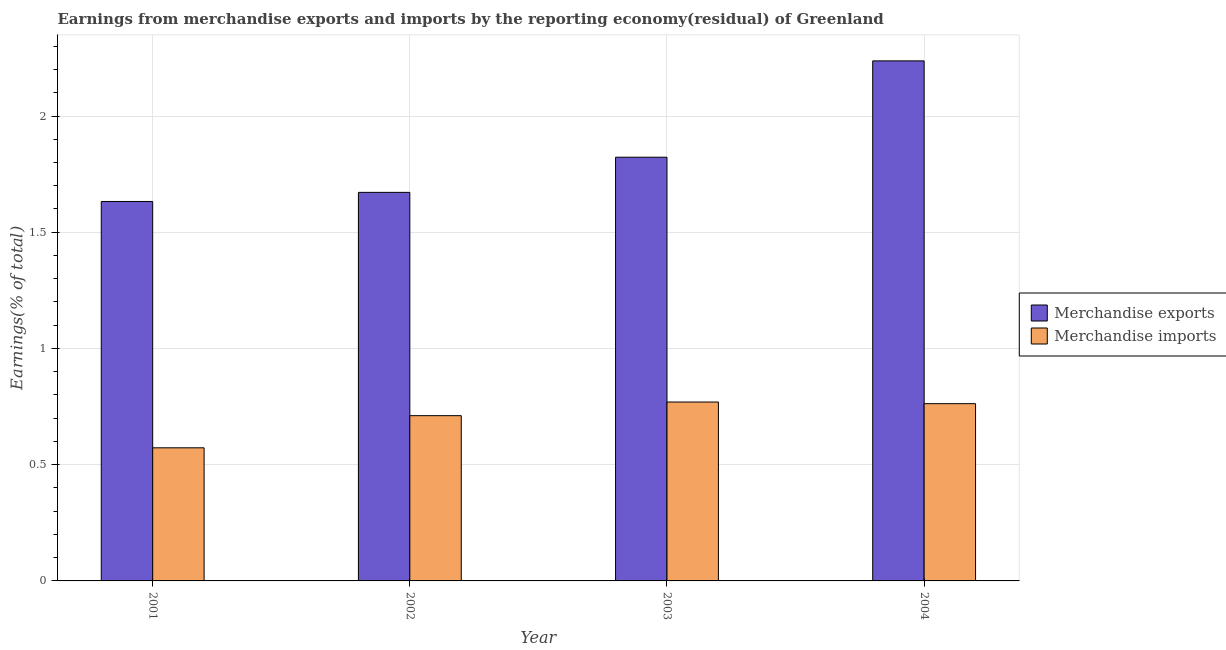What is the label of the 2nd group of bars from the left?
Offer a very short reply. 2002. What is the earnings from merchandise imports in 2002?
Offer a very short reply. 0.71. Across all years, what is the maximum earnings from merchandise exports?
Make the answer very short. 2.24. Across all years, what is the minimum earnings from merchandise exports?
Your answer should be very brief. 1.63. In which year was the earnings from merchandise imports maximum?
Your answer should be very brief. 2003. What is the total earnings from merchandise imports in the graph?
Keep it short and to the point. 2.82. What is the difference between the earnings from merchandise exports in 2001 and that in 2004?
Make the answer very short. -0.6. What is the difference between the earnings from merchandise exports in 2001 and the earnings from merchandise imports in 2004?
Provide a short and direct response. -0.6. What is the average earnings from merchandise exports per year?
Offer a very short reply. 1.84. In how many years, is the earnings from merchandise exports greater than 0.2 %?
Offer a terse response. 4. What is the ratio of the earnings from merchandise imports in 2001 to that in 2003?
Give a very brief answer. 0.74. What is the difference between the highest and the second highest earnings from merchandise imports?
Your answer should be compact. 0.01. What is the difference between the highest and the lowest earnings from merchandise imports?
Keep it short and to the point. 0.2. In how many years, is the earnings from merchandise exports greater than the average earnings from merchandise exports taken over all years?
Ensure brevity in your answer.  1. What does the 1st bar from the right in 2003 represents?
Offer a very short reply. Merchandise imports. Are all the bars in the graph horizontal?
Offer a terse response. No. How many years are there in the graph?
Keep it short and to the point. 4. Are the values on the major ticks of Y-axis written in scientific E-notation?
Give a very brief answer. No. Does the graph contain grids?
Give a very brief answer. Yes. How are the legend labels stacked?
Offer a very short reply. Vertical. What is the title of the graph?
Offer a very short reply. Earnings from merchandise exports and imports by the reporting economy(residual) of Greenland. What is the label or title of the X-axis?
Make the answer very short. Year. What is the label or title of the Y-axis?
Your answer should be very brief. Earnings(% of total). What is the Earnings(% of total) in Merchandise exports in 2001?
Ensure brevity in your answer.  1.63. What is the Earnings(% of total) in Merchandise imports in 2001?
Give a very brief answer. 0.57. What is the Earnings(% of total) in Merchandise exports in 2002?
Your answer should be compact. 1.67. What is the Earnings(% of total) in Merchandise imports in 2002?
Your response must be concise. 0.71. What is the Earnings(% of total) in Merchandise exports in 2003?
Make the answer very short. 1.82. What is the Earnings(% of total) in Merchandise imports in 2003?
Ensure brevity in your answer.  0.77. What is the Earnings(% of total) in Merchandise exports in 2004?
Your answer should be compact. 2.24. What is the Earnings(% of total) of Merchandise imports in 2004?
Your answer should be compact. 0.76. Across all years, what is the maximum Earnings(% of total) in Merchandise exports?
Make the answer very short. 2.24. Across all years, what is the maximum Earnings(% of total) in Merchandise imports?
Offer a very short reply. 0.77. Across all years, what is the minimum Earnings(% of total) in Merchandise exports?
Ensure brevity in your answer.  1.63. Across all years, what is the minimum Earnings(% of total) of Merchandise imports?
Offer a terse response. 0.57. What is the total Earnings(% of total) in Merchandise exports in the graph?
Offer a very short reply. 7.36. What is the total Earnings(% of total) in Merchandise imports in the graph?
Your answer should be compact. 2.82. What is the difference between the Earnings(% of total) in Merchandise exports in 2001 and that in 2002?
Provide a succinct answer. -0.04. What is the difference between the Earnings(% of total) of Merchandise imports in 2001 and that in 2002?
Your answer should be compact. -0.14. What is the difference between the Earnings(% of total) in Merchandise exports in 2001 and that in 2003?
Provide a succinct answer. -0.19. What is the difference between the Earnings(% of total) of Merchandise imports in 2001 and that in 2003?
Your answer should be compact. -0.2. What is the difference between the Earnings(% of total) of Merchandise exports in 2001 and that in 2004?
Make the answer very short. -0.6. What is the difference between the Earnings(% of total) in Merchandise imports in 2001 and that in 2004?
Keep it short and to the point. -0.19. What is the difference between the Earnings(% of total) in Merchandise exports in 2002 and that in 2003?
Ensure brevity in your answer.  -0.15. What is the difference between the Earnings(% of total) of Merchandise imports in 2002 and that in 2003?
Provide a succinct answer. -0.06. What is the difference between the Earnings(% of total) of Merchandise exports in 2002 and that in 2004?
Provide a short and direct response. -0.57. What is the difference between the Earnings(% of total) of Merchandise imports in 2002 and that in 2004?
Make the answer very short. -0.05. What is the difference between the Earnings(% of total) of Merchandise exports in 2003 and that in 2004?
Your response must be concise. -0.41. What is the difference between the Earnings(% of total) of Merchandise imports in 2003 and that in 2004?
Provide a short and direct response. 0.01. What is the difference between the Earnings(% of total) in Merchandise exports in 2001 and the Earnings(% of total) in Merchandise imports in 2002?
Your answer should be very brief. 0.92. What is the difference between the Earnings(% of total) in Merchandise exports in 2001 and the Earnings(% of total) in Merchandise imports in 2003?
Offer a terse response. 0.86. What is the difference between the Earnings(% of total) in Merchandise exports in 2001 and the Earnings(% of total) in Merchandise imports in 2004?
Your answer should be very brief. 0.87. What is the difference between the Earnings(% of total) of Merchandise exports in 2002 and the Earnings(% of total) of Merchandise imports in 2003?
Offer a very short reply. 0.9. What is the difference between the Earnings(% of total) of Merchandise exports in 2002 and the Earnings(% of total) of Merchandise imports in 2004?
Provide a short and direct response. 0.91. What is the difference between the Earnings(% of total) in Merchandise exports in 2003 and the Earnings(% of total) in Merchandise imports in 2004?
Provide a short and direct response. 1.06. What is the average Earnings(% of total) of Merchandise exports per year?
Your answer should be very brief. 1.84. What is the average Earnings(% of total) in Merchandise imports per year?
Provide a short and direct response. 0.7. In the year 2001, what is the difference between the Earnings(% of total) in Merchandise exports and Earnings(% of total) in Merchandise imports?
Make the answer very short. 1.06. In the year 2002, what is the difference between the Earnings(% of total) in Merchandise exports and Earnings(% of total) in Merchandise imports?
Give a very brief answer. 0.96. In the year 2003, what is the difference between the Earnings(% of total) in Merchandise exports and Earnings(% of total) in Merchandise imports?
Give a very brief answer. 1.05. In the year 2004, what is the difference between the Earnings(% of total) in Merchandise exports and Earnings(% of total) in Merchandise imports?
Provide a short and direct response. 1.47. What is the ratio of the Earnings(% of total) in Merchandise exports in 2001 to that in 2002?
Your answer should be compact. 0.98. What is the ratio of the Earnings(% of total) in Merchandise imports in 2001 to that in 2002?
Offer a very short reply. 0.81. What is the ratio of the Earnings(% of total) in Merchandise exports in 2001 to that in 2003?
Offer a very short reply. 0.9. What is the ratio of the Earnings(% of total) of Merchandise imports in 2001 to that in 2003?
Keep it short and to the point. 0.74. What is the ratio of the Earnings(% of total) of Merchandise exports in 2001 to that in 2004?
Ensure brevity in your answer.  0.73. What is the ratio of the Earnings(% of total) in Merchandise imports in 2001 to that in 2004?
Ensure brevity in your answer.  0.75. What is the ratio of the Earnings(% of total) in Merchandise exports in 2002 to that in 2003?
Your answer should be compact. 0.92. What is the ratio of the Earnings(% of total) in Merchandise imports in 2002 to that in 2003?
Your answer should be compact. 0.92. What is the ratio of the Earnings(% of total) of Merchandise exports in 2002 to that in 2004?
Your answer should be very brief. 0.75. What is the ratio of the Earnings(% of total) in Merchandise imports in 2002 to that in 2004?
Ensure brevity in your answer.  0.93. What is the ratio of the Earnings(% of total) of Merchandise exports in 2003 to that in 2004?
Make the answer very short. 0.81. What is the ratio of the Earnings(% of total) in Merchandise imports in 2003 to that in 2004?
Give a very brief answer. 1.01. What is the difference between the highest and the second highest Earnings(% of total) of Merchandise exports?
Keep it short and to the point. 0.41. What is the difference between the highest and the second highest Earnings(% of total) of Merchandise imports?
Provide a short and direct response. 0.01. What is the difference between the highest and the lowest Earnings(% of total) of Merchandise exports?
Ensure brevity in your answer.  0.6. What is the difference between the highest and the lowest Earnings(% of total) of Merchandise imports?
Ensure brevity in your answer.  0.2. 